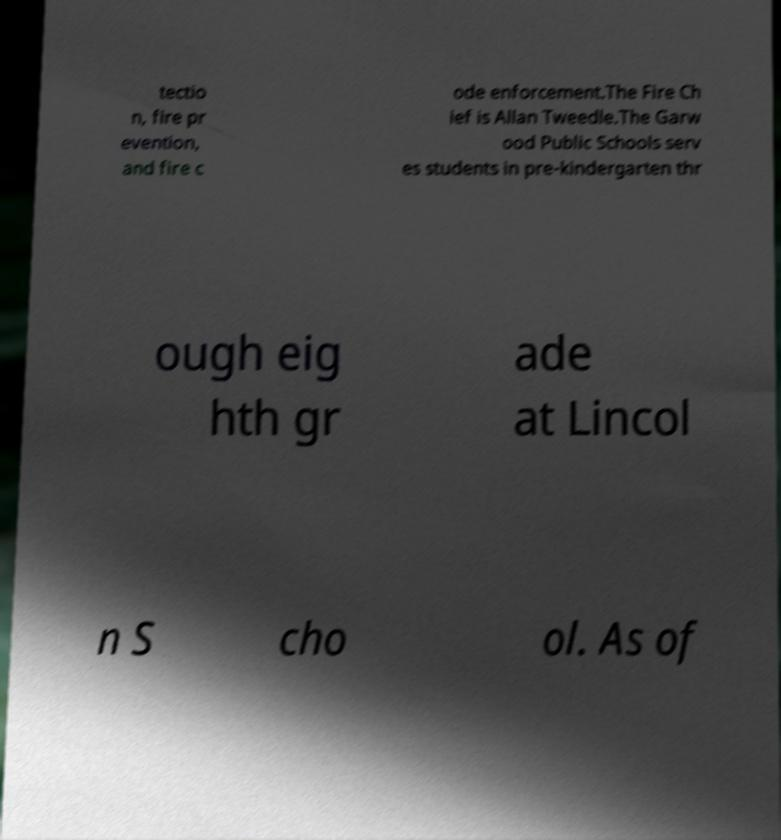Please read and relay the text visible in this image. What does it say? tectio n, fire pr evention, and fire c ode enforcement.The Fire Ch ief is Allan Tweedle.The Garw ood Public Schools serv es students in pre-kindergarten thr ough eig hth gr ade at Lincol n S cho ol. As of 